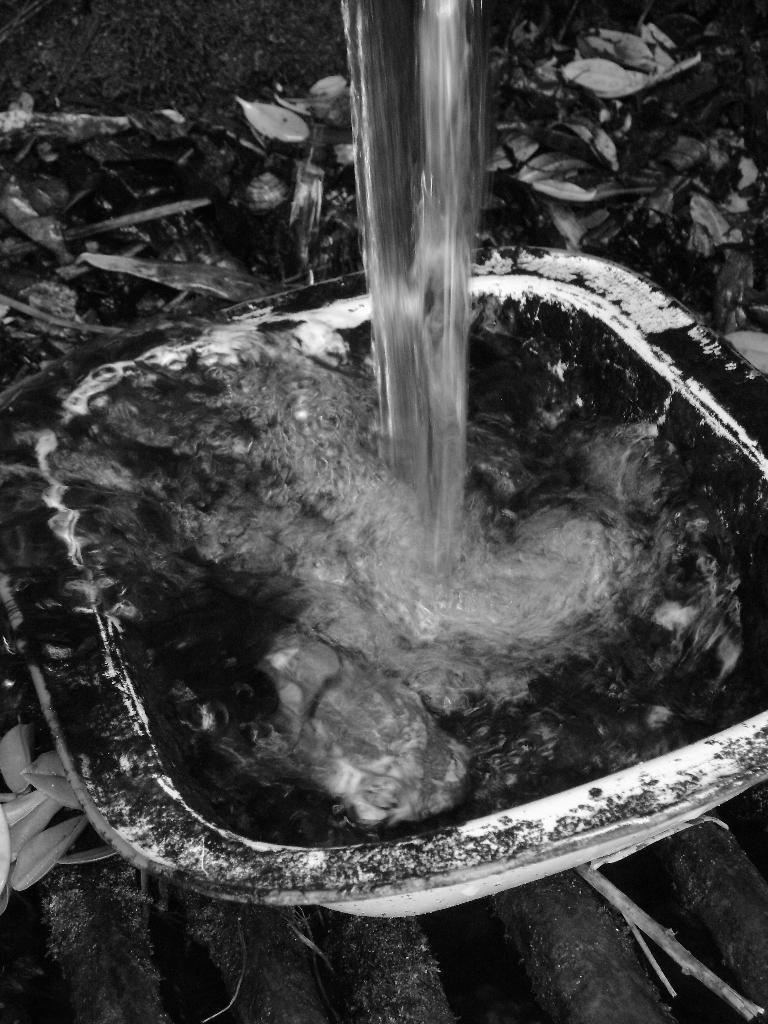What is happening with the water in the image? The water is flowing into a pot in the image. What can be found around the pot? There are dried leaves and branches around the pot. What type of ink is being used to write a fictional story about a discovery in the image? There is no ink or writing present in the image, and no story about a discovery is depicted. 